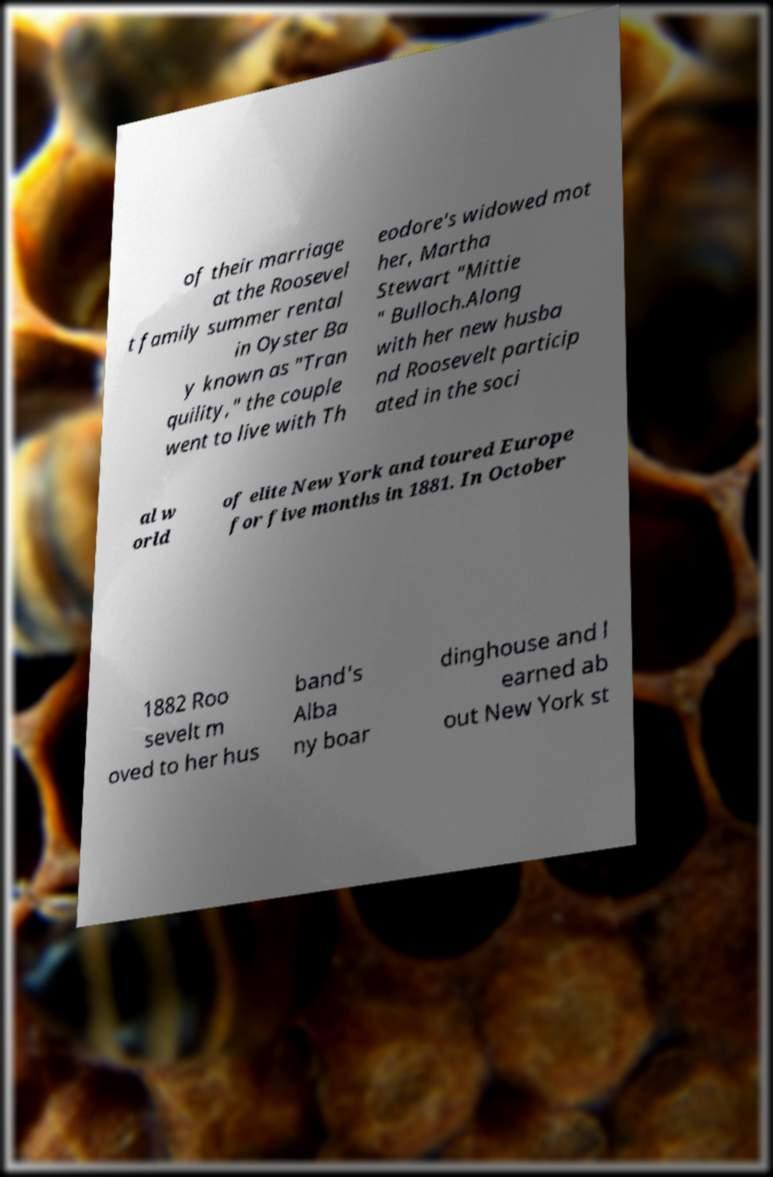Could you assist in decoding the text presented in this image and type it out clearly? of their marriage at the Roosevel t family summer rental in Oyster Ba y known as "Tran quility," the couple went to live with Th eodore's widowed mot her, Martha Stewart "Mittie " Bulloch.Along with her new husba nd Roosevelt particip ated in the soci al w orld of elite New York and toured Europe for five months in 1881. In October 1882 Roo sevelt m oved to her hus band's Alba ny boar dinghouse and l earned ab out New York st 